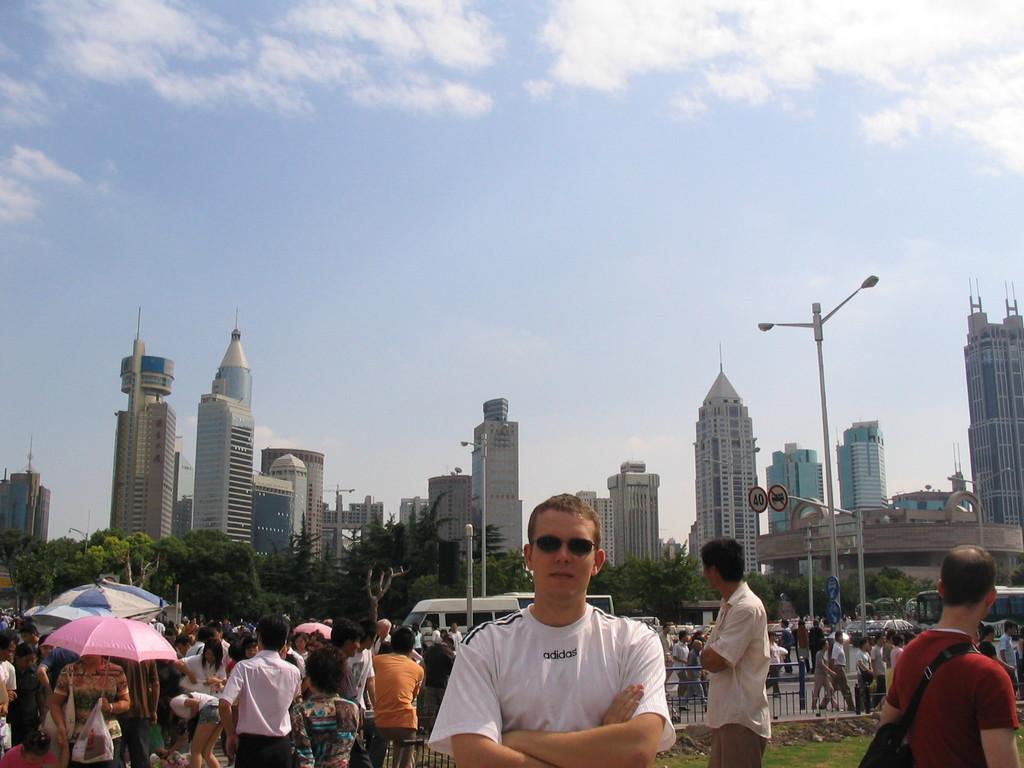Can you describe this image briefly? In the picture we can see a man standing in a white T-shirt and behind him we can see many people are standing and in the background, we can see the pole with lights, trees, buildings and the sky with clouds. 